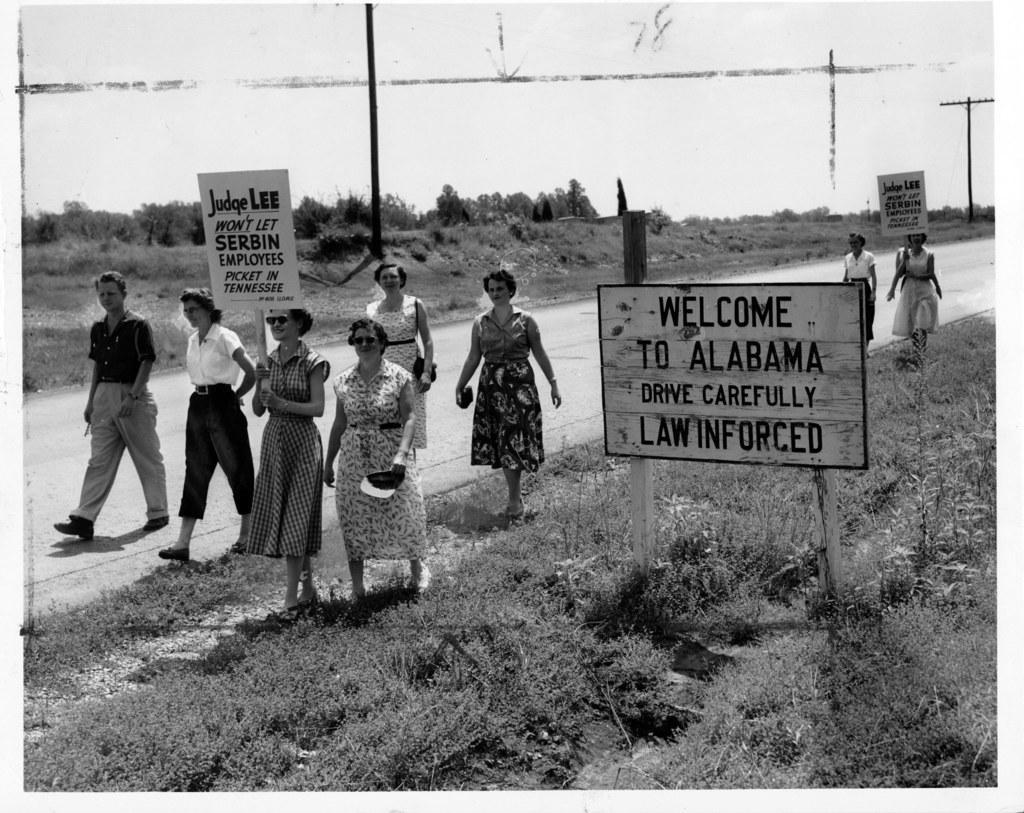Describe this image in one or two sentences. In this picture we can see a group of people walking on the road, two people are holding posters, here we can see a name board, grass, trees, electric poles and we can see sky in the background. 